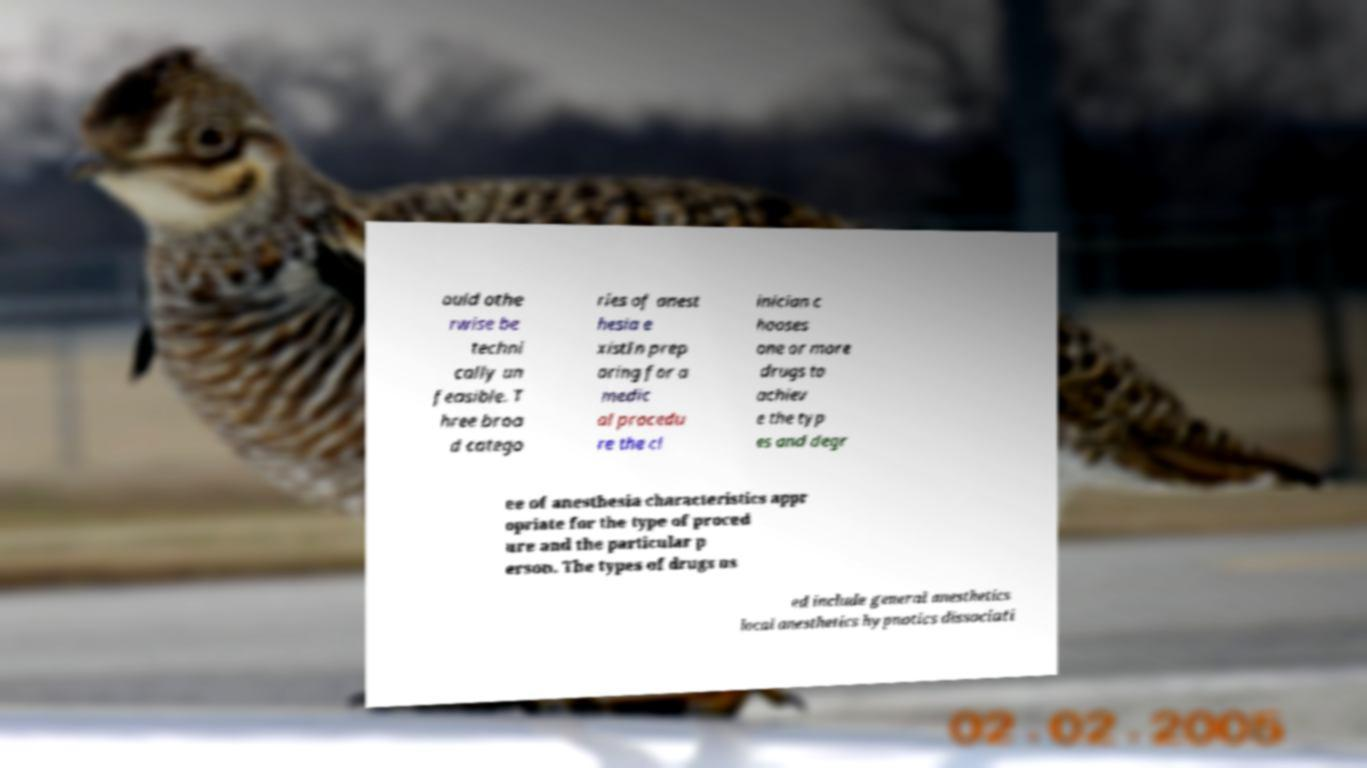For documentation purposes, I need the text within this image transcribed. Could you provide that? ould othe rwise be techni cally un feasible. T hree broa d catego ries of anest hesia e xistIn prep aring for a medic al procedu re the cl inician c hooses one or more drugs to achiev e the typ es and degr ee of anesthesia characteristics appr opriate for the type of proced ure and the particular p erson. The types of drugs us ed include general anesthetics local anesthetics hypnotics dissociati 